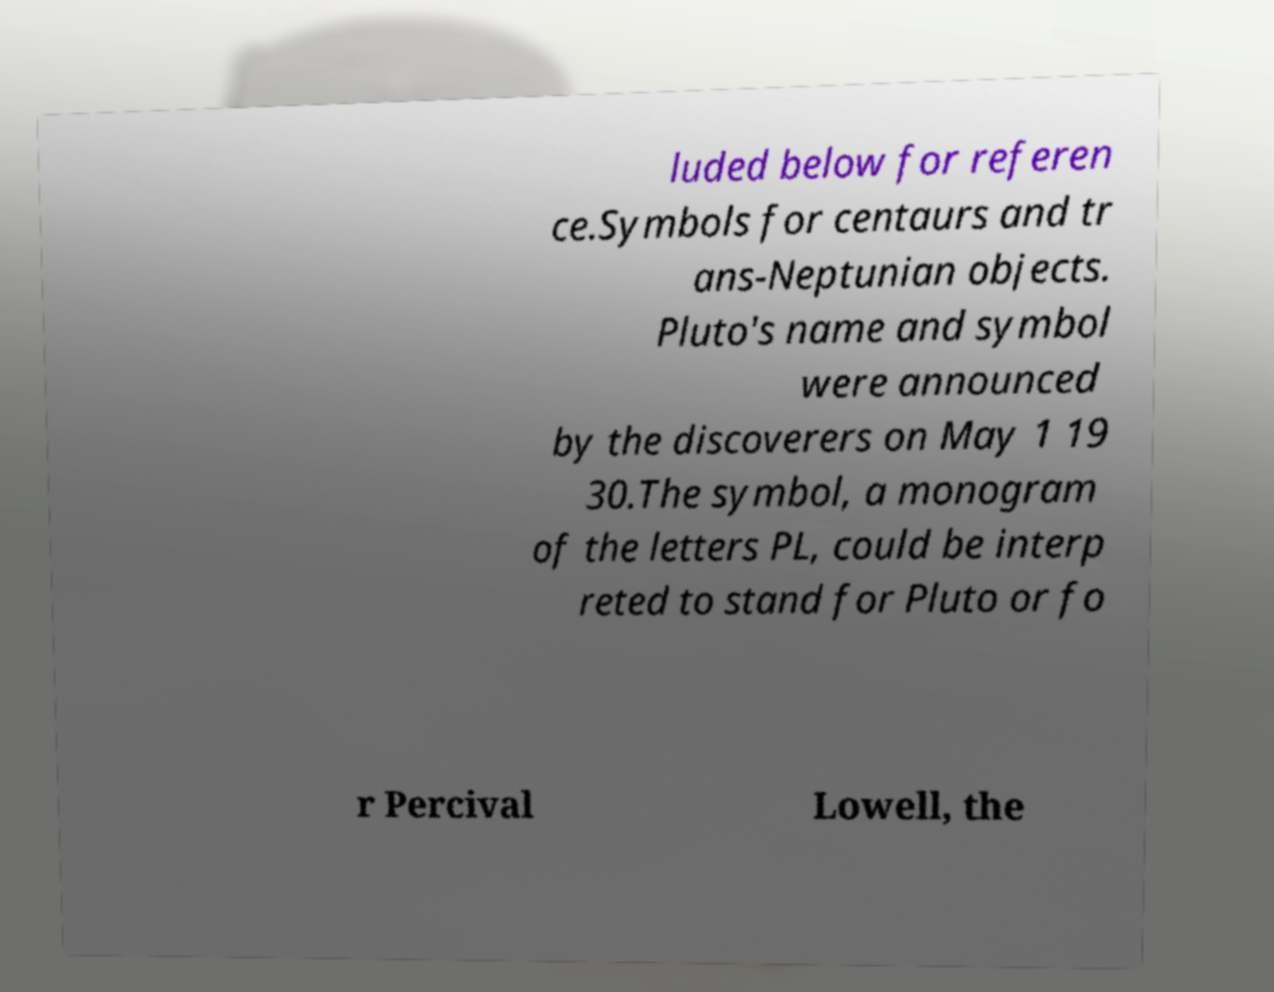What messages or text are displayed in this image? I need them in a readable, typed format. luded below for referen ce.Symbols for centaurs and tr ans-Neptunian objects. Pluto's name and symbol were announced by the discoverers on May 1 19 30.The symbol, a monogram of the letters PL, could be interp reted to stand for Pluto or fo r Percival Lowell, the 